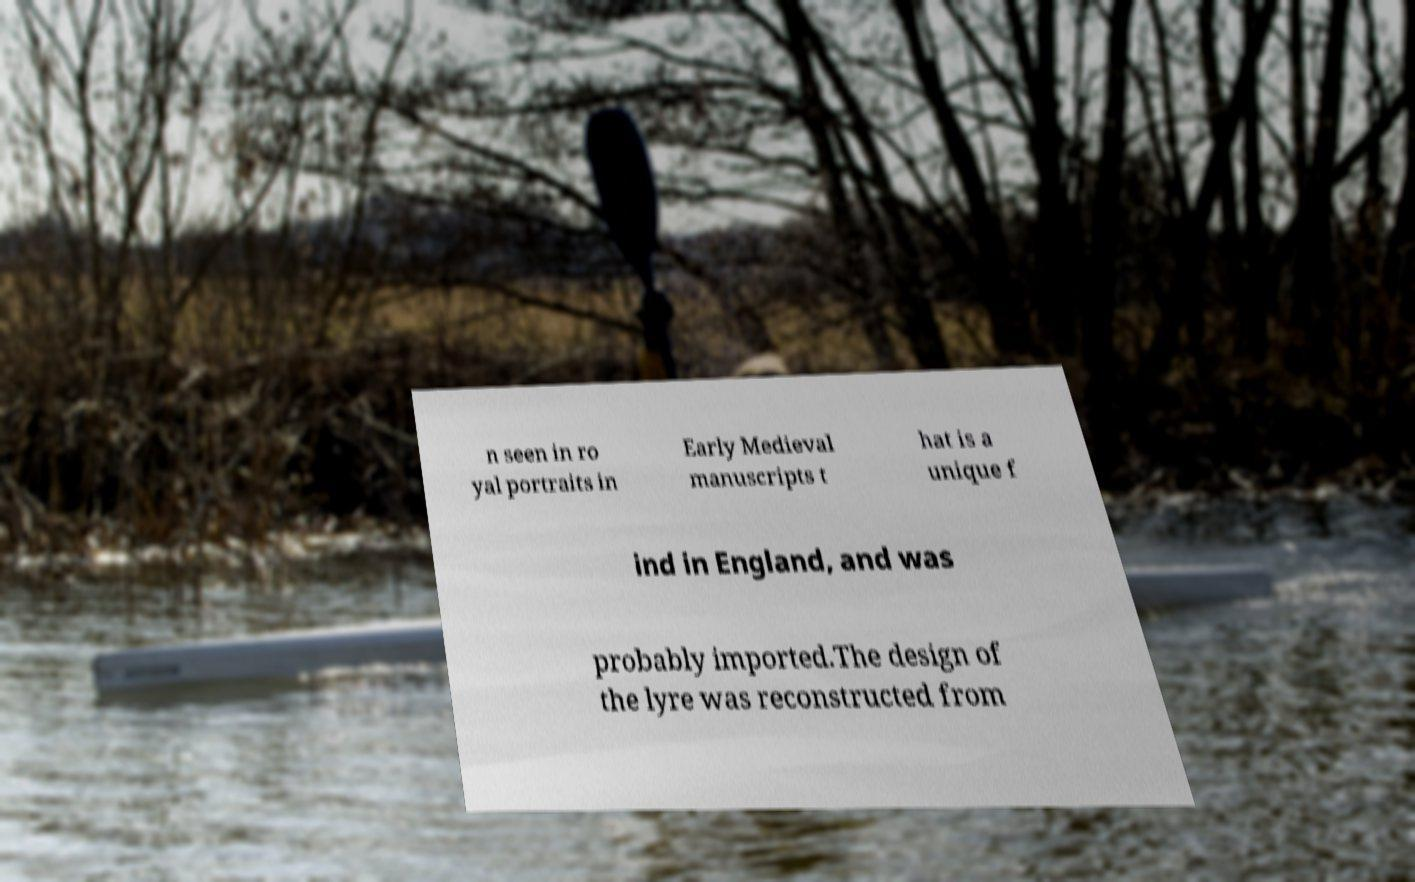For documentation purposes, I need the text within this image transcribed. Could you provide that? n seen in ro yal portraits in Early Medieval manuscripts t hat is a unique f ind in England, and was probably imported.The design of the lyre was reconstructed from 